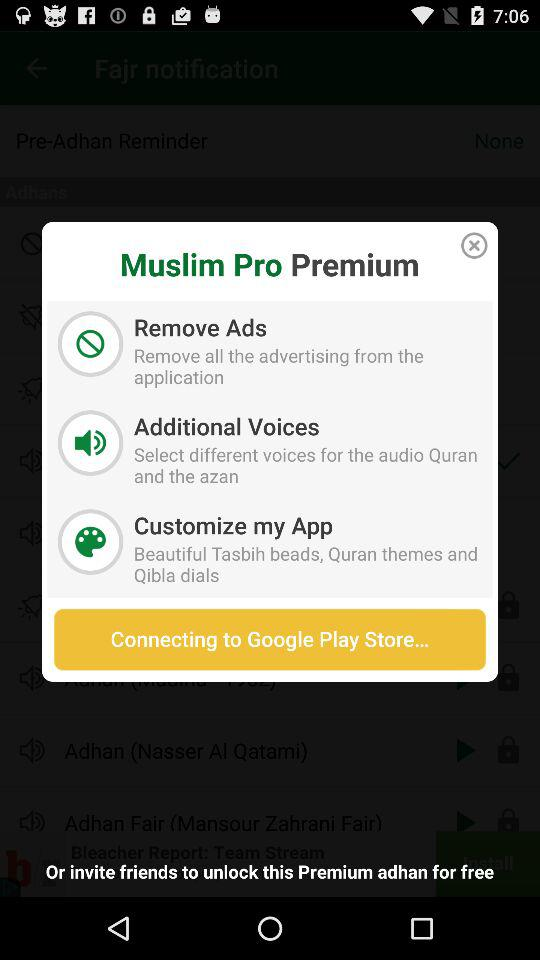What is the application name? The application name is "Muslim Pro". 